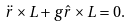<formula> <loc_0><loc_0><loc_500><loc_500>\ddot { r } \times L + g \hat { r } \times L = 0 .</formula> 